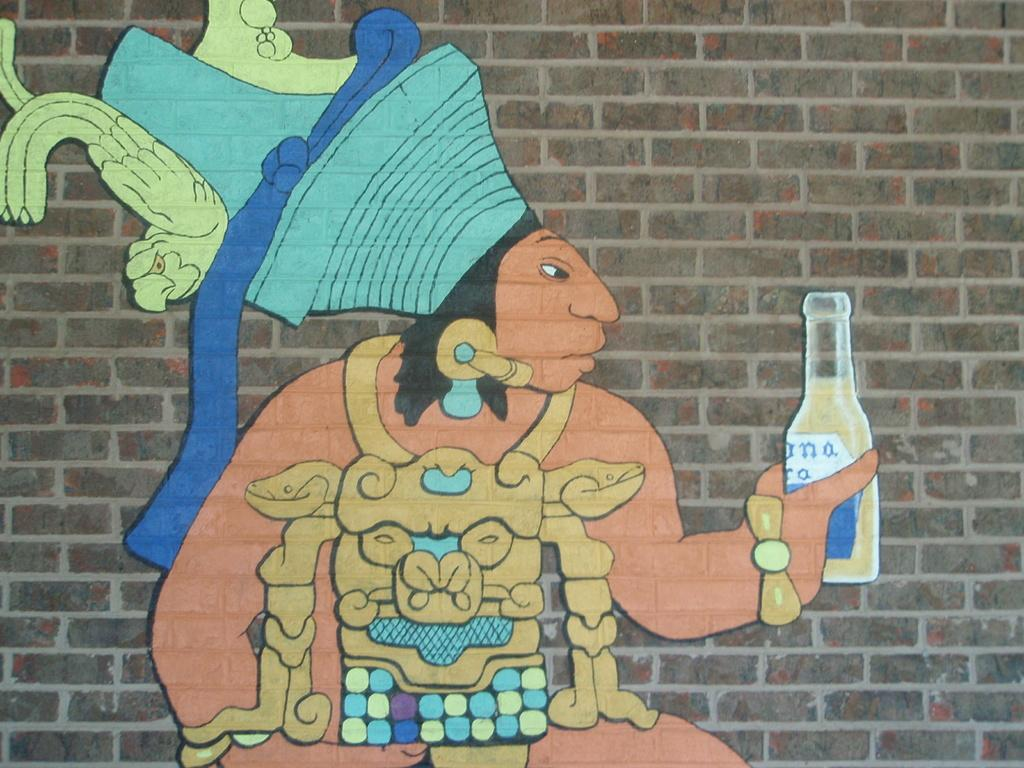<image>
Offer a succinct explanation of the picture presented. a man is holding a bottle in the painting with a on it 